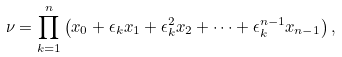Convert formula to latex. <formula><loc_0><loc_0><loc_500><loc_500>\nu = \prod _ { k = 1 } ^ { n } \left ( x _ { 0 } + \epsilon _ { k } x _ { 1 } + \epsilon _ { k } ^ { 2 } x _ { 2 } + \cdots + \epsilon ^ { n - 1 } _ { k } x _ { n - 1 } \right ) ,</formula> 